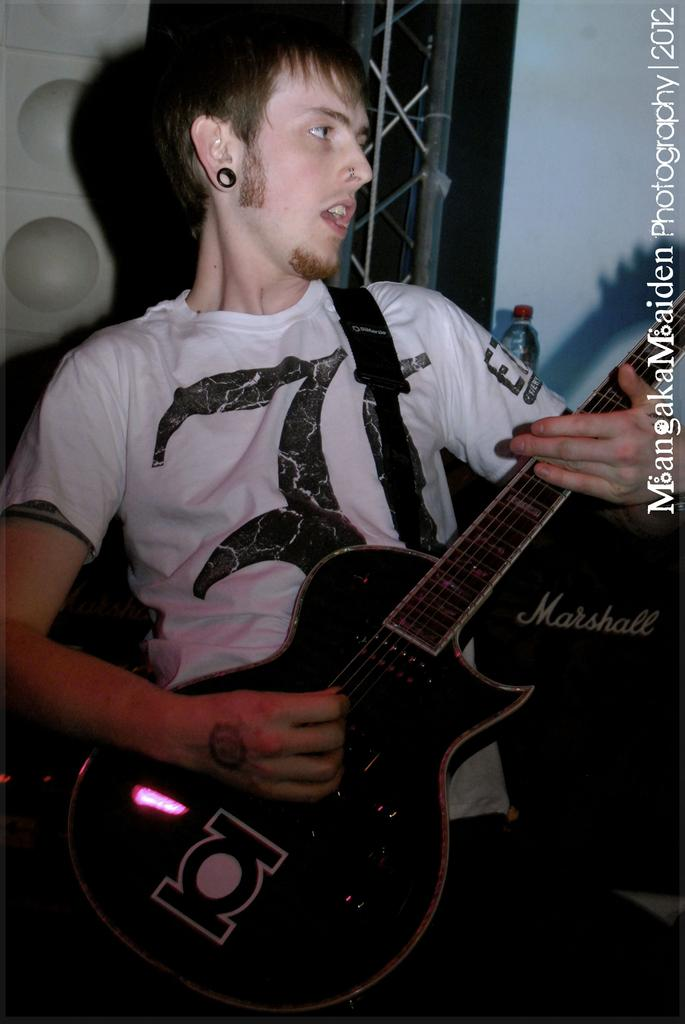What is the man in the image holding? The man is holding a guitar. What is the man doing with the guitar? The man is playing the guitar. What can be seen in the background of the image? There is a steel rod, a bottle, and a wall in the background of the image. How many birds are in the flock that is flying over the man in the image? There is no flock of birds visible in the image. 